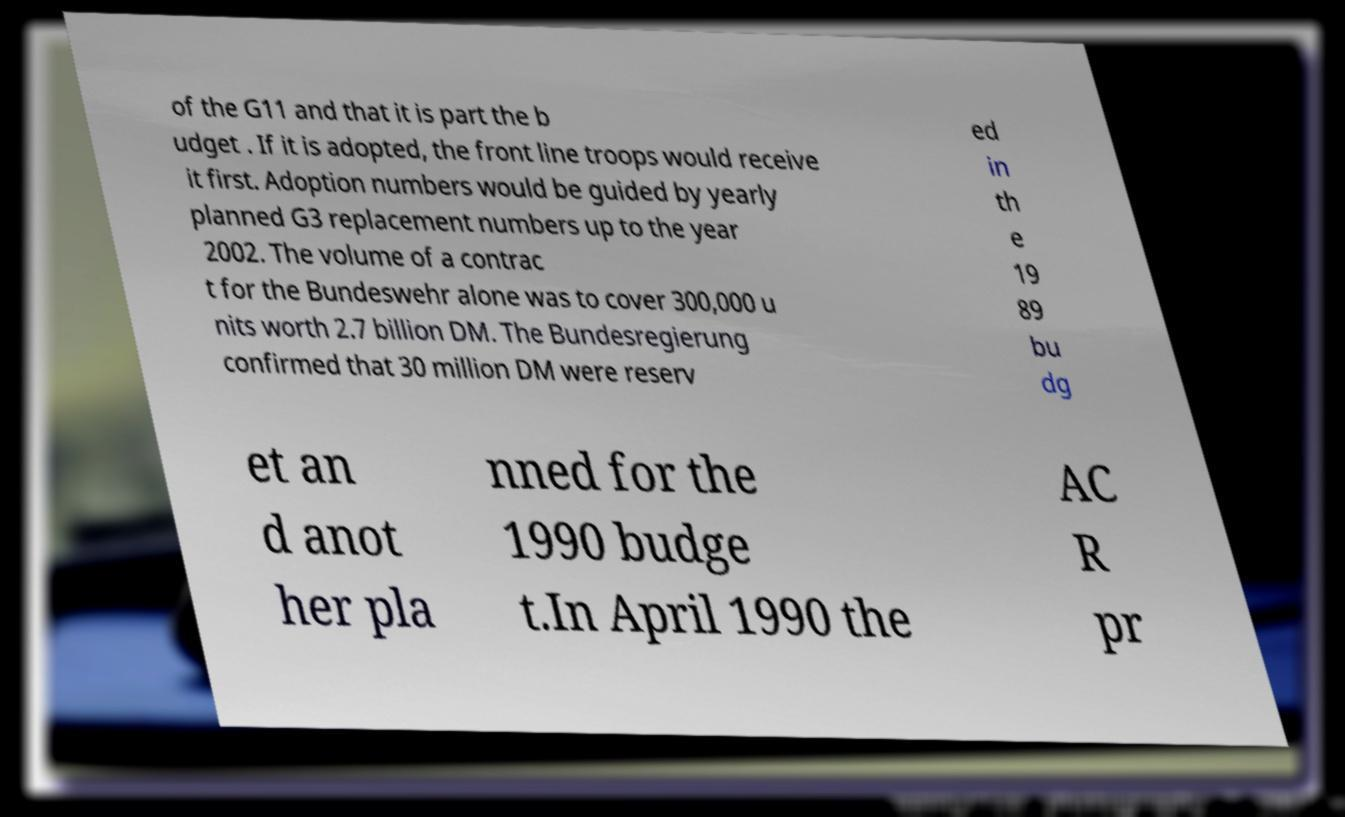Can you read and provide the text displayed in the image?This photo seems to have some interesting text. Can you extract and type it out for me? of the G11 and that it is part the b udget . If it is adopted, the front line troops would receive it first. Adoption numbers would be guided by yearly planned G3 replacement numbers up to the year 2002. The volume of a contrac t for the Bundeswehr alone was to cover 300,000 u nits worth 2.7 billion DM. The Bundesregierung confirmed that 30 million DM were reserv ed in th e 19 89 bu dg et an d anot her pla nned for the 1990 budge t.In April 1990 the AC R pr 